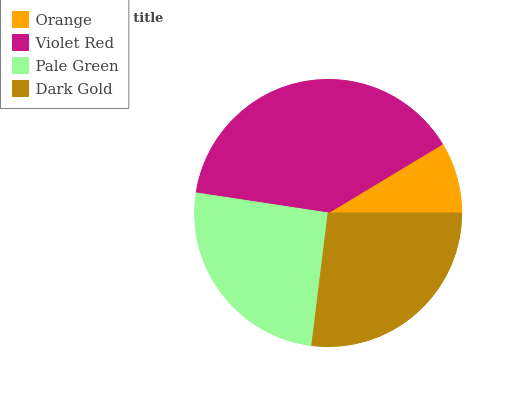Is Orange the minimum?
Answer yes or no. Yes. Is Violet Red the maximum?
Answer yes or no. Yes. Is Pale Green the minimum?
Answer yes or no. No. Is Pale Green the maximum?
Answer yes or no. No. Is Violet Red greater than Pale Green?
Answer yes or no. Yes. Is Pale Green less than Violet Red?
Answer yes or no. Yes. Is Pale Green greater than Violet Red?
Answer yes or no. No. Is Violet Red less than Pale Green?
Answer yes or no. No. Is Dark Gold the high median?
Answer yes or no. Yes. Is Pale Green the low median?
Answer yes or no. Yes. Is Orange the high median?
Answer yes or no. No. Is Orange the low median?
Answer yes or no. No. 